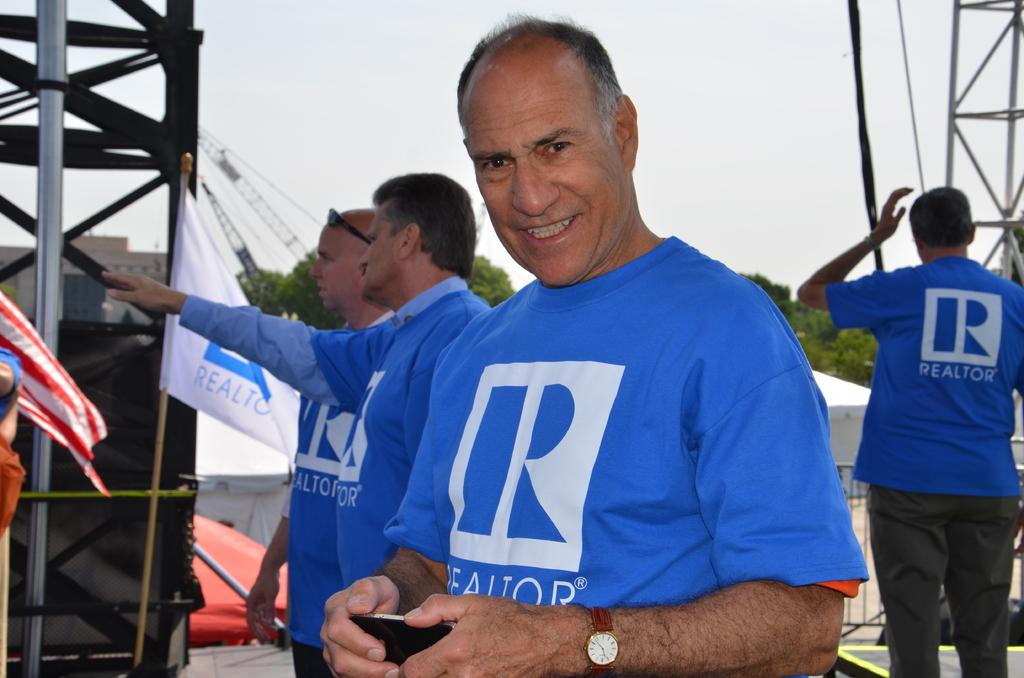Provide a one-sentence caption for the provided image. several men wearing blue t-shirts with Realtor on them. 